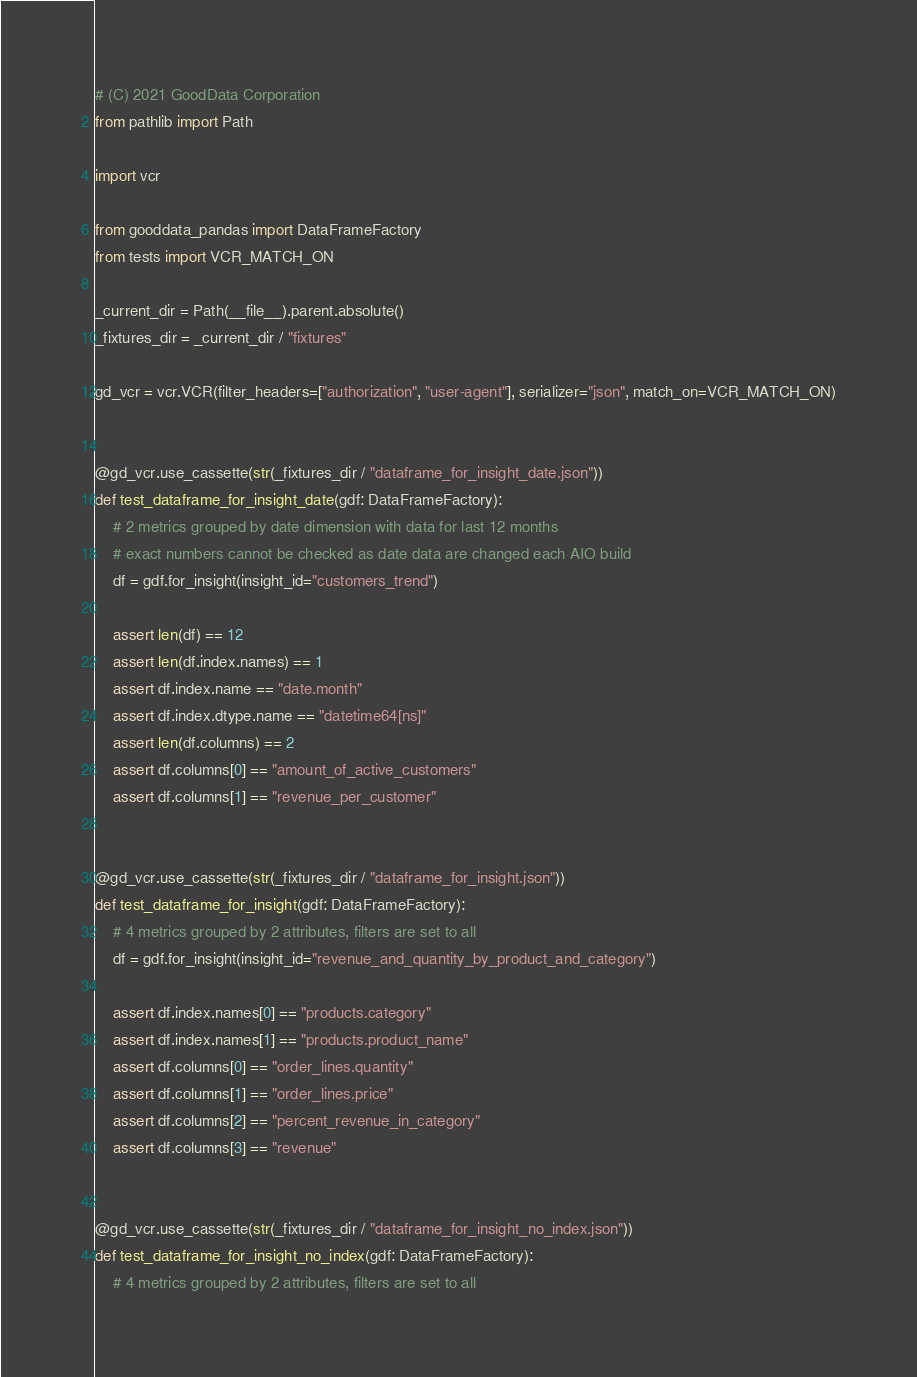<code> <loc_0><loc_0><loc_500><loc_500><_Python_># (C) 2021 GoodData Corporation
from pathlib import Path

import vcr

from gooddata_pandas import DataFrameFactory
from tests import VCR_MATCH_ON

_current_dir = Path(__file__).parent.absolute()
_fixtures_dir = _current_dir / "fixtures"

gd_vcr = vcr.VCR(filter_headers=["authorization", "user-agent"], serializer="json", match_on=VCR_MATCH_ON)


@gd_vcr.use_cassette(str(_fixtures_dir / "dataframe_for_insight_date.json"))
def test_dataframe_for_insight_date(gdf: DataFrameFactory):
    # 2 metrics grouped by date dimension with data for last 12 months
    # exact numbers cannot be checked as date data are changed each AIO build
    df = gdf.for_insight(insight_id="customers_trend")

    assert len(df) == 12
    assert len(df.index.names) == 1
    assert df.index.name == "date.month"
    assert df.index.dtype.name == "datetime64[ns]"
    assert len(df.columns) == 2
    assert df.columns[0] == "amount_of_active_customers"
    assert df.columns[1] == "revenue_per_customer"


@gd_vcr.use_cassette(str(_fixtures_dir / "dataframe_for_insight.json"))
def test_dataframe_for_insight(gdf: DataFrameFactory):
    # 4 metrics grouped by 2 attributes, filters are set to all
    df = gdf.for_insight(insight_id="revenue_and_quantity_by_product_and_category")

    assert df.index.names[0] == "products.category"
    assert df.index.names[1] == "products.product_name"
    assert df.columns[0] == "order_lines.quantity"
    assert df.columns[1] == "order_lines.price"
    assert df.columns[2] == "percent_revenue_in_category"
    assert df.columns[3] == "revenue"


@gd_vcr.use_cassette(str(_fixtures_dir / "dataframe_for_insight_no_index.json"))
def test_dataframe_for_insight_no_index(gdf: DataFrameFactory):
    # 4 metrics grouped by 2 attributes, filters are set to all</code> 